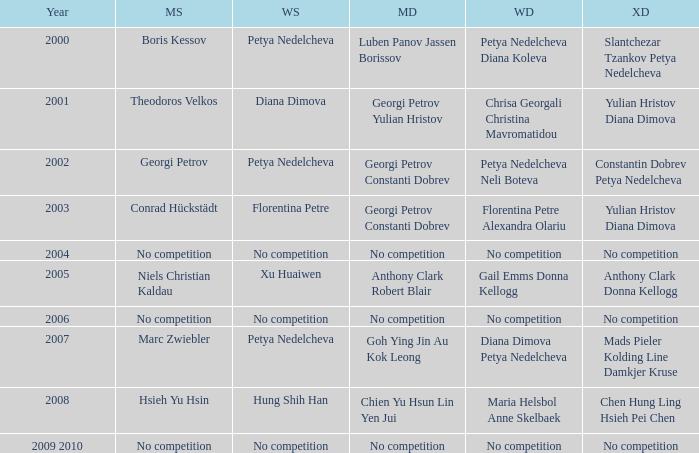I'm looking to parse the entire table for insights. Could you assist me with that? {'header': ['Year', 'MS', 'WS', 'MD', 'WD', 'XD'], 'rows': [['2000', 'Boris Kessov', 'Petya Nedelcheva', 'Luben Panov Jassen Borissov', 'Petya Nedelcheva Diana Koleva', 'Slantchezar Tzankov Petya Nedelcheva'], ['2001', 'Theodoros Velkos', 'Diana Dimova', 'Georgi Petrov Yulian Hristov', 'Chrisa Georgali Christina Mavromatidou', 'Yulian Hristov Diana Dimova'], ['2002', 'Georgi Petrov', 'Petya Nedelcheva', 'Georgi Petrov Constanti Dobrev', 'Petya Nedelcheva Neli Boteva', 'Constantin Dobrev Petya Nedelcheva'], ['2003', 'Conrad Hückstädt', 'Florentina Petre', 'Georgi Petrov Constanti Dobrev', 'Florentina Petre Alexandra Olariu', 'Yulian Hristov Diana Dimova'], ['2004', 'No competition', 'No competition', 'No competition', 'No competition', 'No competition'], ['2005', 'Niels Christian Kaldau', 'Xu Huaiwen', 'Anthony Clark Robert Blair', 'Gail Emms Donna Kellogg', 'Anthony Clark Donna Kellogg'], ['2006', 'No competition', 'No competition', 'No competition', 'No competition', 'No competition'], ['2007', 'Marc Zwiebler', 'Petya Nedelcheva', 'Goh Ying Jin Au Kok Leong', 'Diana Dimova Petya Nedelcheva', 'Mads Pieler Kolding Line Damkjer Kruse'], ['2008', 'Hsieh Yu Hsin', 'Hung Shih Han', 'Chien Yu Hsun Lin Yen Jui', 'Maria Helsbol Anne Skelbaek', 'Chen Hung Ling Hsieh Pei Chen'], ['2009 2010', 'No competition', 'No competition', 'No competition', 'No competition', 'No competition']]} In what year was there no competition for women? 2004, 2006, 2009 2010. 